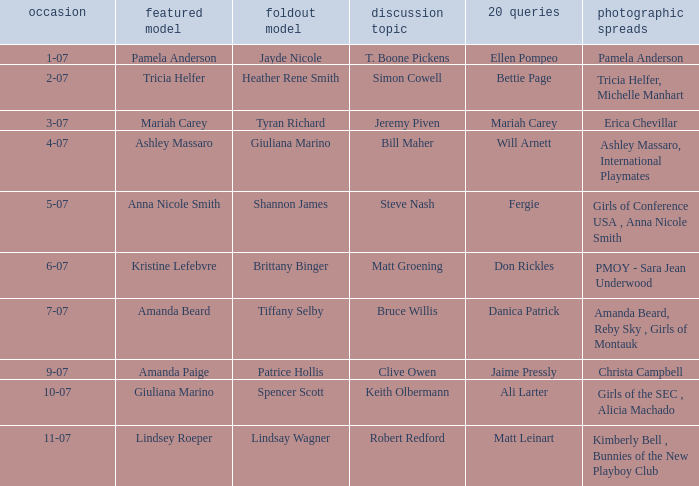Who was the cover model when the issue's pictorials was pmoy - sara jean underwood? Kristine Lefebvre. 